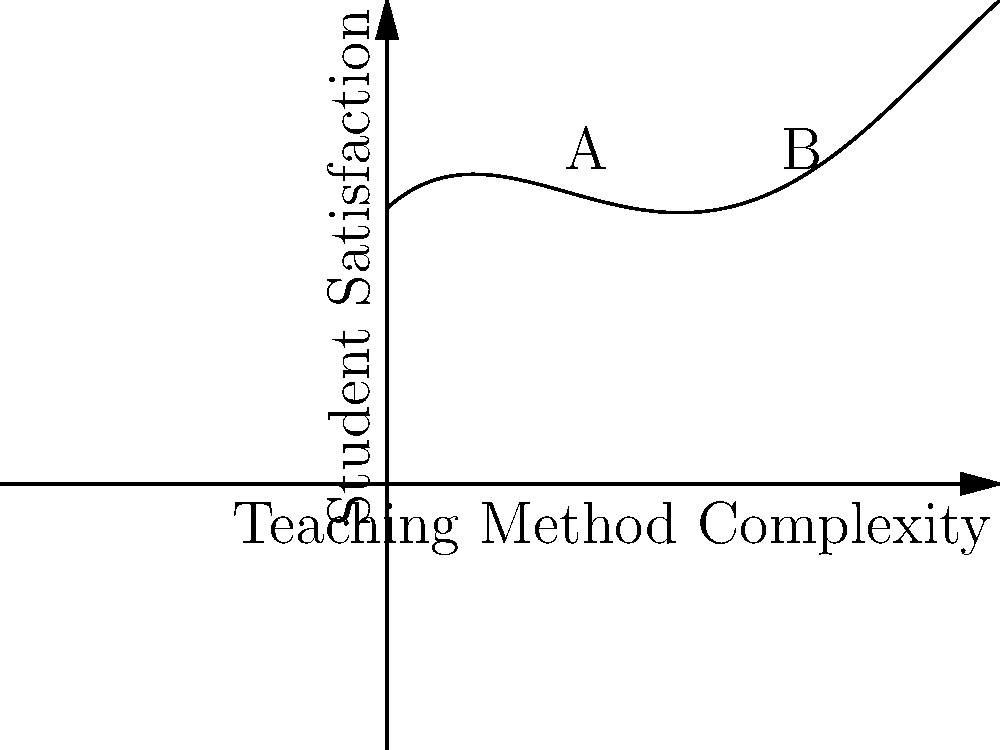The graph represents student satisfaction ratings for different teaching methods, where the x-axis denotes the complexity of the teaching method and the y-axis represents the student satisfaction level. As a negotiator advocating for fair treatment of faculty, you're analyzing this data to recommend optimal teaching approaches. Find the x-coordinates of the inflection points (labeled A and B) in this curve, which could indicate transitions between different teaching effectiveness levels. To find the inflection points, we need to follow these steps:

1) The function given by the graph is approximately:
   $$f(x) = -0.05x^4 + 0.6x^3 - 2x^2 + 2x + 5$$

2) Inflection points occur where the second derivative of the function equals zero. So, we need to find $f''(x)$ and solve $f''(x) = 0$.

3) First derivative:
   $$f'(x) = -0.2x^3 + 1.8x^2 - 4x + 2$$

4) Second derivative:
   $$f''(x) = -0.6x^2 + 3.6x - 4$$

5) Solve $f''(x) = 0$:
   $$-0.6x^2 + 3.6x - 4 = 0$$

6) This is a quadratic equation. We can solve it using the quadratic formula:
   $$x = \frac{-b \pm \sqrt{b^2 - 4ac}}{2a}$$
   where $a = -0.6$, $b = 3.6$, and $c = -4$

7) Plugging in these values:
   $$x = \frac{-3.6 \pm \sqrt{3.6^2 - 4(-0.6)(-4)}}{2(-0.6)}$$
   $$= \frac{-3.6 \pm \sqrt{12.96 - 9.6}}{-1.2}$$
   $$= \frac{-3.6 \pm \sqrt{3.36}}{-1.2}$$
   $$= \frac{-3.6 \pm 1.83}{-1.2}$$

8) This gives us two solutions:
   $$x_1 = \frac{-3.6 + 1.83}{-1.2} \approx 1.34$$
   $$x_2 = \frac{-3.6 - 1.83}{-1.2} \approx 3.66$$

These x-coordinates correspond to the inflection points A and B in the graph.
Answer: The x-coordinates of the inflection points are approximately 1.34 and 3.66. 